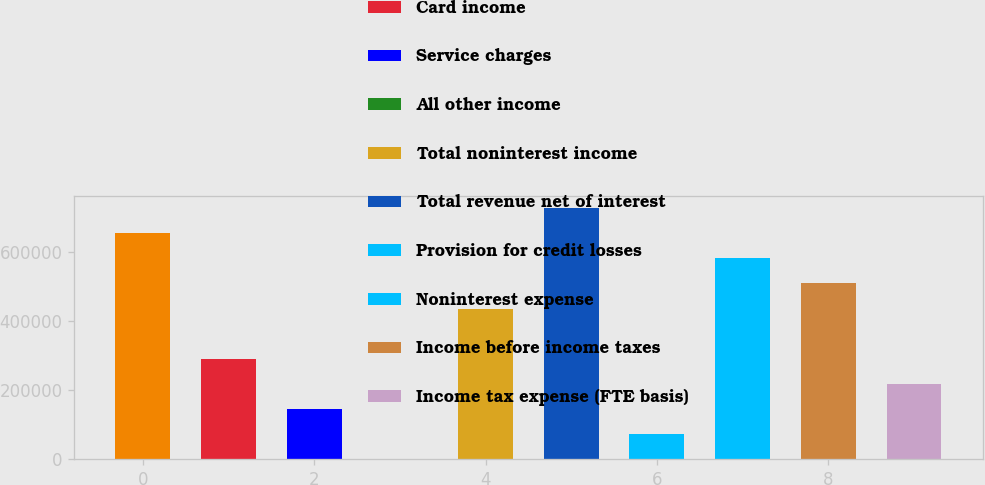<chart> <loc_0><loc_0><loc_500><loc_500><bar_chart><fcel>Net interest income (FTE<fcel>Card income<fcel>Service charges<fcel>All other income<fcel>Total noninterest income<fcel>Total revenue net of interest<fcel>Provision for credit losses<fcel>Noninterest expense<fcel>Income before income taxes<fcel>Income tax expense (FTE basis)<nl><fcel>652905<fcel>290401<fcel>145399<fcel>397<fcel>435402<fcel>725406<fcel>72897.9<fcel>580404<fcel>507903<fcel>217900<nl></chart> 